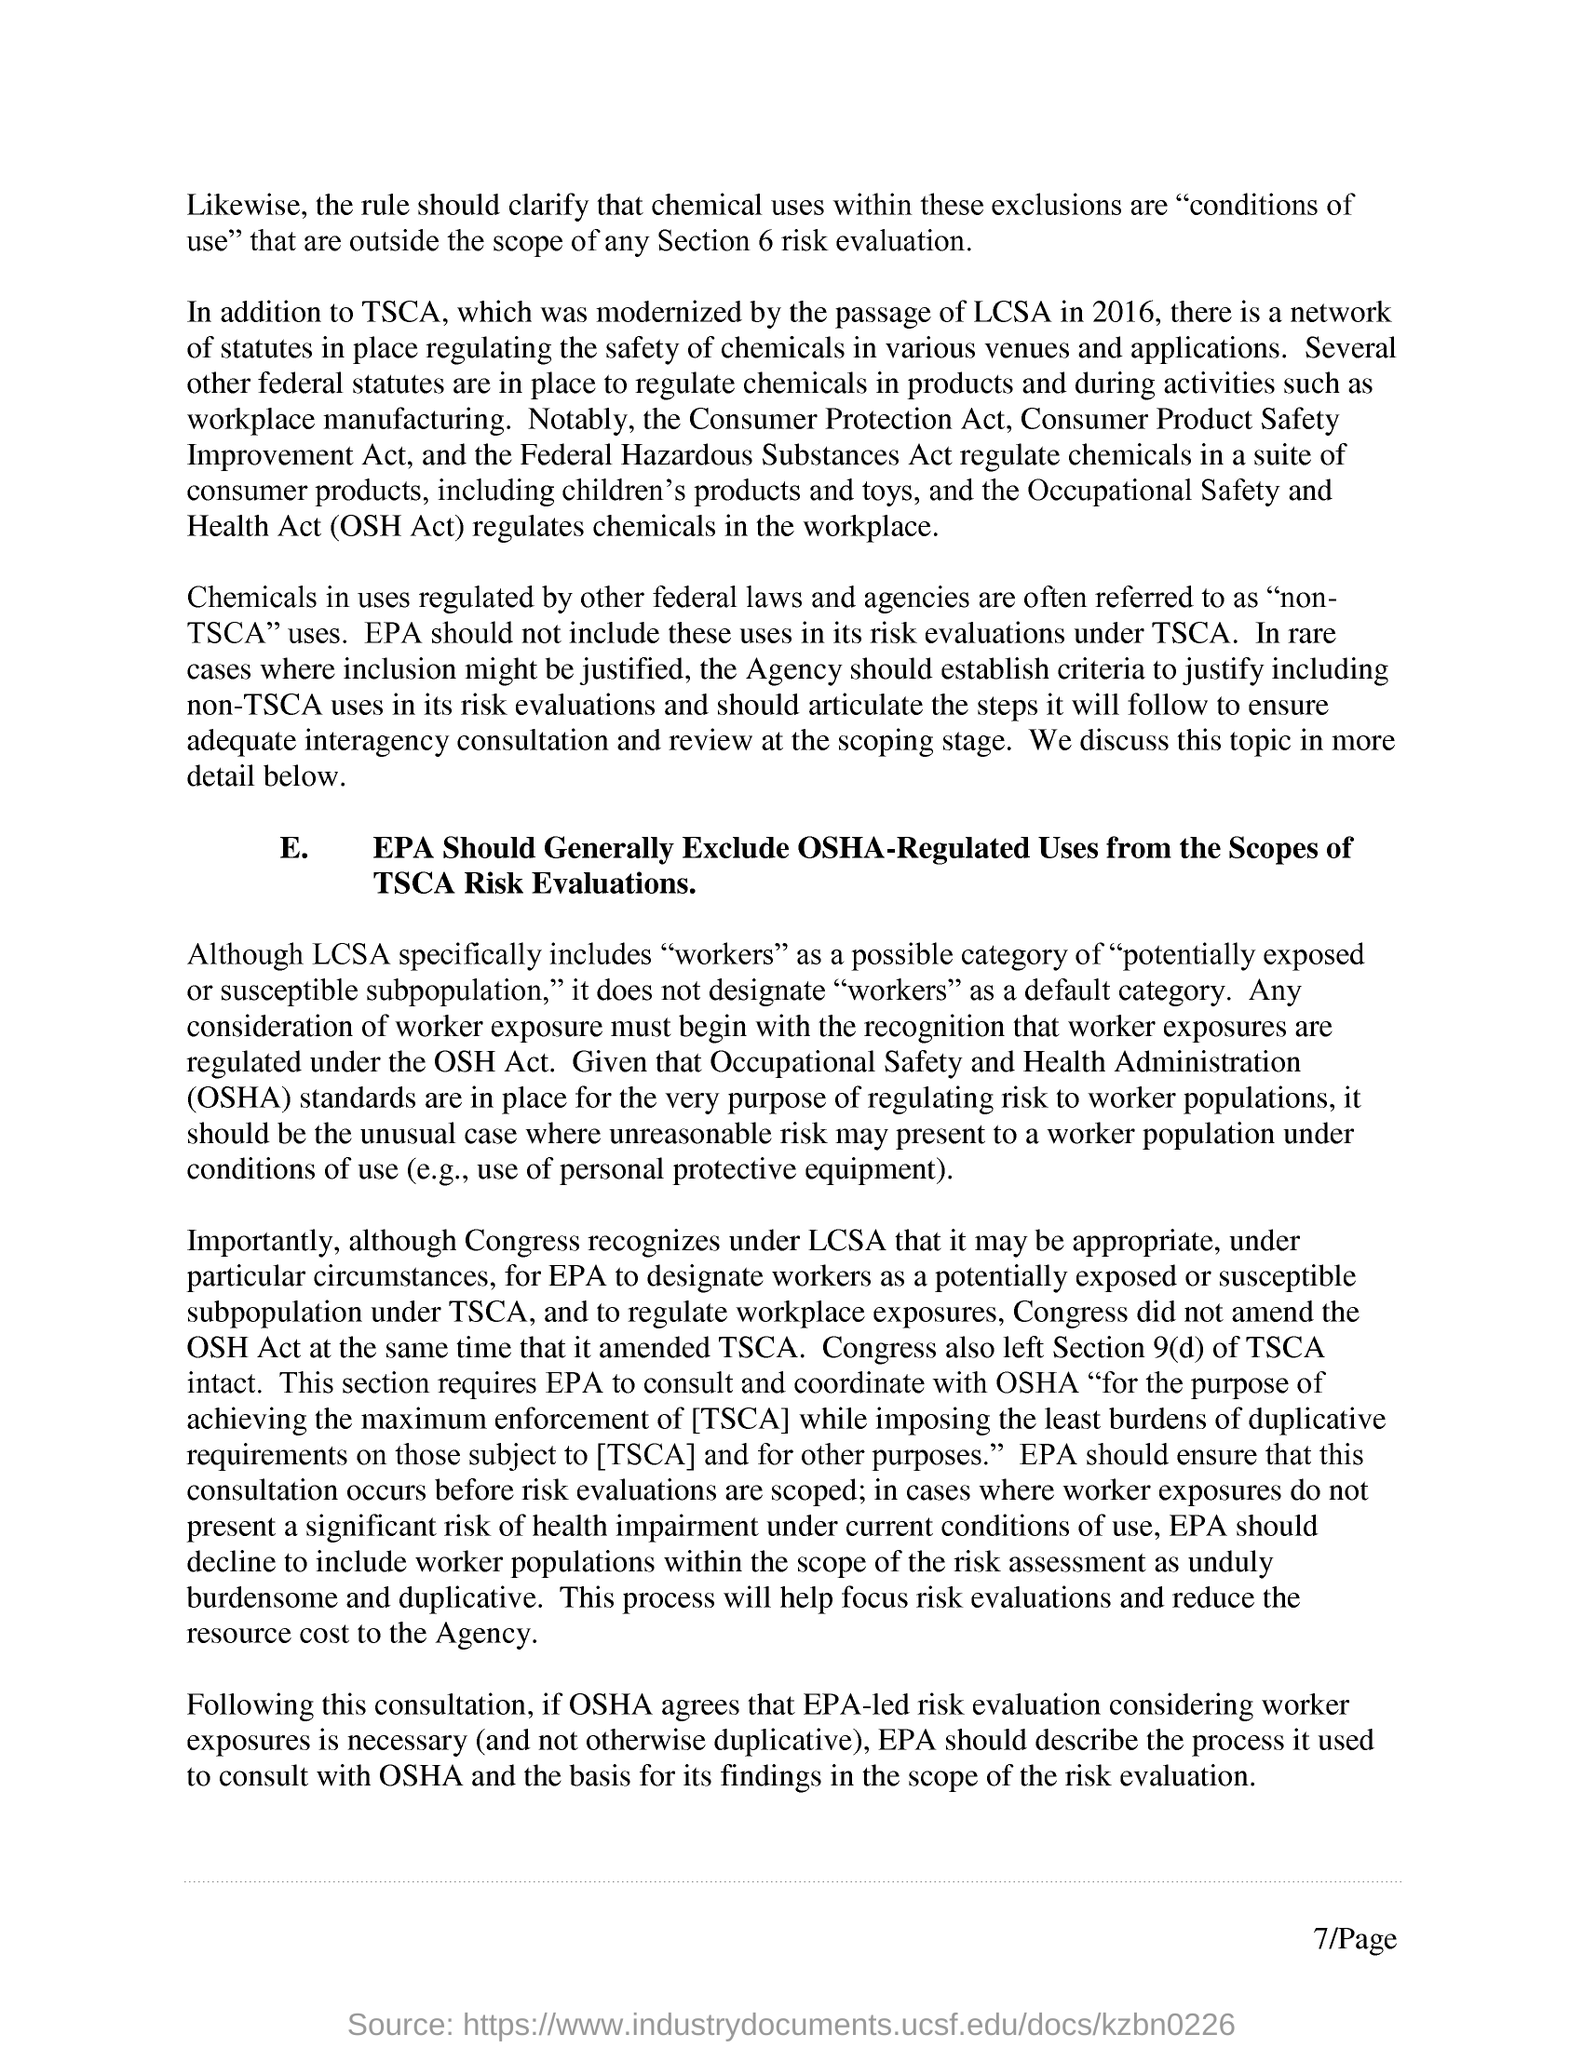Mention a couple of crucial points in this snapshot. The page number is 7. 